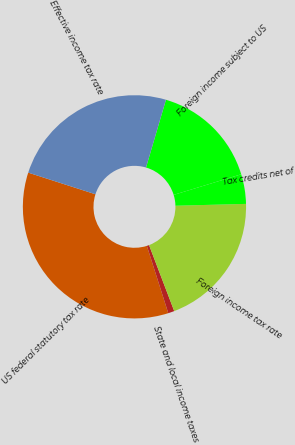Convert chart. <chart><loc_0><loc_0><loc_500><loc_500><pie_chart><fcel>US federal statutory tax rate<fcel>State and local income taxes<fcel>Foreign income tax rate<fcel>Tax credits net of<fcel>Foreign income subject to US<fcel>Effective income tax rate<nl><fcel>34.86%<fcel>0.9%<fcel>19.62%<fcel>4.29%<fcel>15.74%<fcel>24.6%<nl></chart> 